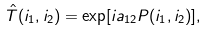Convert formula to latex. <formula><loc_0><loc_0><loc_500><loc_500>\hat { T } ( { i } _ { 1 } , { i } _ { 2 } ) = \exp [ i a _ { 1 2 } P ( { i } _ { 1 } , { i } _ { 2 } ) ] ,</formula> 